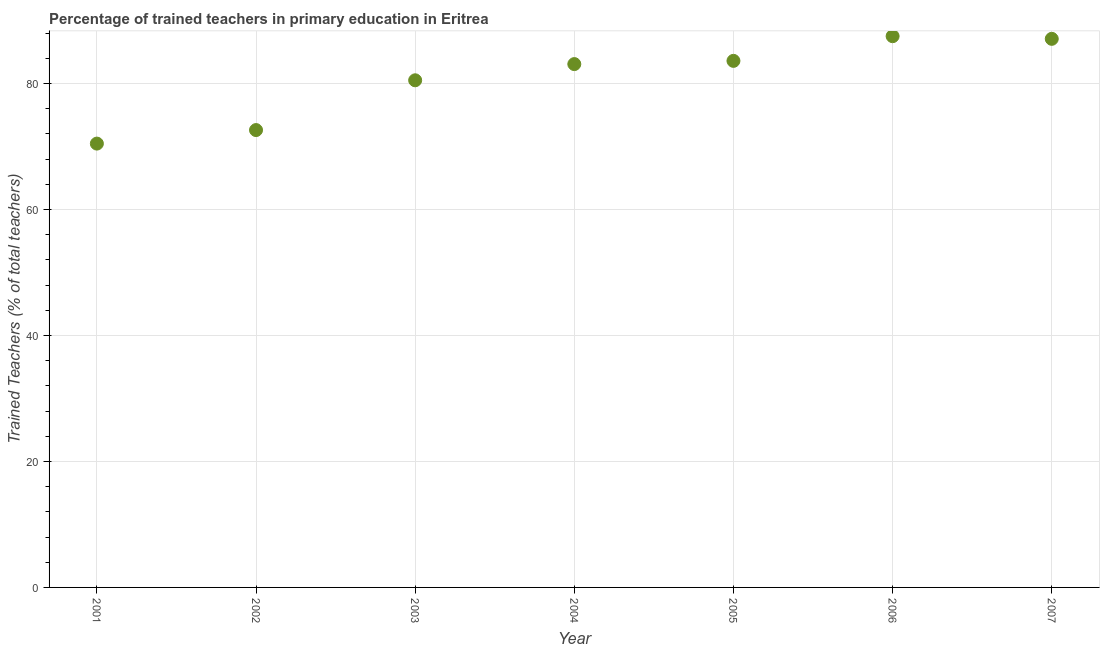What is the percentage of trained teachers in 2004?
Keep it short and to the point. 83.09. Across all years, what is the maximum percentage of trained teachers?
Offer a terse response. 87.52. Across all years, what is the minimum percentage of trained teachers?
Keep it short and to the point. 70.47. In which year was the percentage of trained teachers minimum?
Give a very brief answer. 2001. What is the sum of the percentage of trained teachers?
Offer a terse response. 564.94. What is the difference between the percentage of trained teachers in 2004 and 2005?
Offer a very short reply. -0.51. What is the average percentage of trained teachers per year?
Make the answer very short. 80.71. What is the median percentage of trained teachers?
Your response must be concise. 83.09. In how many years, is the percentage of trained teachers greater than 52 %?
Keep it short and to the point. 7. What is the ratio of the percentage of trained teachers in 2002 to that in 2005?
Your answer should be compact. 0.87. Is the difference between the percentage of trained teachers in 2001 and 2006 greater than the difference between any two years?
Your answer should be very brief. Yes. What is the difference between the highest and the second highest percentage of trained teachers?
Provide a succinct answer. 0.42. Is the sum of the percentage of trained teachers in 2002 and 2006 greater than the maximum percentage of trained teachers across all years?
Offer a very short reply. Yes. What is the difference between the highest and the lowest percentage of trained teachers?
Your response must be concise. 17.05. How many dotlines are there?
Your answer should be compact. 1. How many years are there in the graph?
Give a very brief answer. 7. What is the difference between two consecutive major ticks on the Y-axis?
Your answer should be very brief. 20. Does the graph contain grids?
Your answer should be very brief. Yes. What is the title of the graph?
Provide a succinct answer. Percentage of trained teachers in primary education in Eritrea. What is the label or title of the Y-axis?
Offer a terse response. Trained Teachers (% of total teachers). What is the Trained Teachers (% of total teachers) in 2001?
Your answer should be very brief. 70.47. What is the Trained Teachers (% of total teachers) in 2002?
Give a very brief answer. 72.62. What is the Trained Teachers (% of total teachers) in 2003?
Provide a succinct answer. 80.52. What is the Trained Teachers (% of total teachers) in 2004?
Provide a short and direct response. 83.09. What is the Trained Teachers (% of total teachers) in 2005?
Your answer should be compact. 83.61. What is the Trained Teachers (% of total teachers) in 2006?
Your answer should be compact. 87.52. What is the Trained Teachers (% of total teachers) in 2007?
Your answer should be very brief. 87.11. What is the difference between the Trained Teachers (% of total teachers) in 2001 and 2002?
Offer a very short reply. -2.15. What is the difference between the Trained Teachers (% of total teachers) in 2001 and 2003?
Your answer should be very brief. -10.05. What is the difference between the Trained Teachers (% of total teachers) in 2001 and 2004?
Your response must be concise. -12.62. What is the difference between the Trained Teachers (% of total teachers) in 2001 and 2005?
Provide a succinct answer. -13.14. What is the difference between the Trained Teachers (% of total teachers) in 2001 and 2006?
Offer a very short reply. -17.05. What is the difference between the Trained Teachers (% of total teachers) in 2001 and 2007?
Offer a very short reply. -16.63. What is the difference between the Trained Teachers (% of total teachers) in 2002 and 2003?
Provide a succinct answer. -7.9. What is the difference between the Trained Teachers (% of total teachers) in 2002 and 2004?
Provide a succinct answer. -10.48. What is the difference between the Trained Teachers (% of total teachers) in 2002 and 2005?
Offer a very short reply. -10.99. What is the difference between the Trained Teachers (% of total teachers) in 2002 and 2006?
Your answer should be compact. -14.9. What is the difference between the Trained Teachers (% of total teachers) in 2002 and 2007?
Provide a succinct answer. -14.49. What is the difference between the Trained Teachers (% of total teachers) in 2003 and 2004?
Your response must be concise. -2.57. What is the difference between the Trained Teachers (% of total teachers) in 2003 and 2005?
Offer a very short reply. -3.08. What is the difference between the Trained Teachers (% of total teachers) in 2003 and 2006?
Keep it short and to the point. -7. What is the difference between the Trained Teachers (% of total teachers) in 2003 and 2007?
Your answer should be compact. -6.58. What is the difference between the Trained Teachers (% of total teachers) in 2004 and 2005?
Keep it short and to the point. -0.51. What is the difference between the Trained Teachers (% of total teachers) in 2004 and 2006?
Provide a succinct answer. -4.43. What is the difference between the Trained Teachers (% of total teachers) in 2004 and 2007?
Your response must be concise. -4.01. What is the difference between the Trained Teachers (% of total teachers) in 2005 and 2006?
Provide a short and direct response. -3.92. What is the difference between the Trained Teachers (% of total teachers) in 2005 and 2007?
Offer a very short reply. -3.5. What is the difference between the Trained Teachers (% of total teachers) in 2006 and 2007?
Your response must be concise. 0.42. What is the ratio of the Trained Teachers (% of total teachers) in 2001 to that in 2003?
Provide a short and direct response. 0.88. What is the ratio of the Trained Teachers (% of total teachers) in 2001 to that in 2004?
Keep it short and to the point. 0.85. What is the ratio of the Trained Teachers (% of total teachers) in 2001 to that in 2005?
Your answer should be very brief. 0.84. What is the ratio of the Trained Teachers (% of total teachers) in 2001 to that in 2006?
Your answer should be compact. 0.81. What is the ratio of the Trained Teachers (% of total teachers) in 2001 to that in 2007?
Offer a very short reply. 0.81. What is the ratio of the Trained Teachers (% of total teachers) in 2002 to that in 2003?
Your response must be concise. 0.9. What is the ratio of the Trained Teachers (% of total teachers) in 2002 to that in 2004?
Offer a very short reply. 0.87. What is the ratio of the Trained Teachers (% of total teachers) in 2002 to that in 2005?
Your answer should be compact. 0.87. What is the ratio of the Trained Teachers (% of total teachers) in 2002 to that in 2006?
Offer a terse response. 0.83. What is the ratio of the Trained Teachers (% of total teachers) in 2002 to that in 2007?
Offer a terse response. 0.83. What is the ratio of the Trained Teachers (% of total teachers) in 2003 to that in 2006?
Your answer should be very brief. 0.92. What is the ratio of the Trained Teachers (% of total teachers) in 2003 to that in 2007?
Provide a short and direct response. 0.92. What is the ratio of the Trained Teachers (% of total teachers) in 2004 to that in 2005?
Provide a succinct answer. 0.99. What is the ratio of the Trained Teachers (% of total teachers) in 2004 to that in 2006?
Make the answer very short. 0.95. What is the ratio of the Trained Teachers (% of total teachers) in 2004 to that in 2007?
Your response must be concise. 0.95. What is the ratio of the Trained Teachers (% of total teachers) in 2005 to that in 2006?
Provide a succinct answer. 0.95. What is the ratio of the Trained Teachers (% of total teachers) in 2005 to that in 2007?
Offer a very short reply. 0.96. What is the ratio of the Trained Teachers (% of total teachers) in 2006 to that in 2007?
Give a very brief answer. 1. 